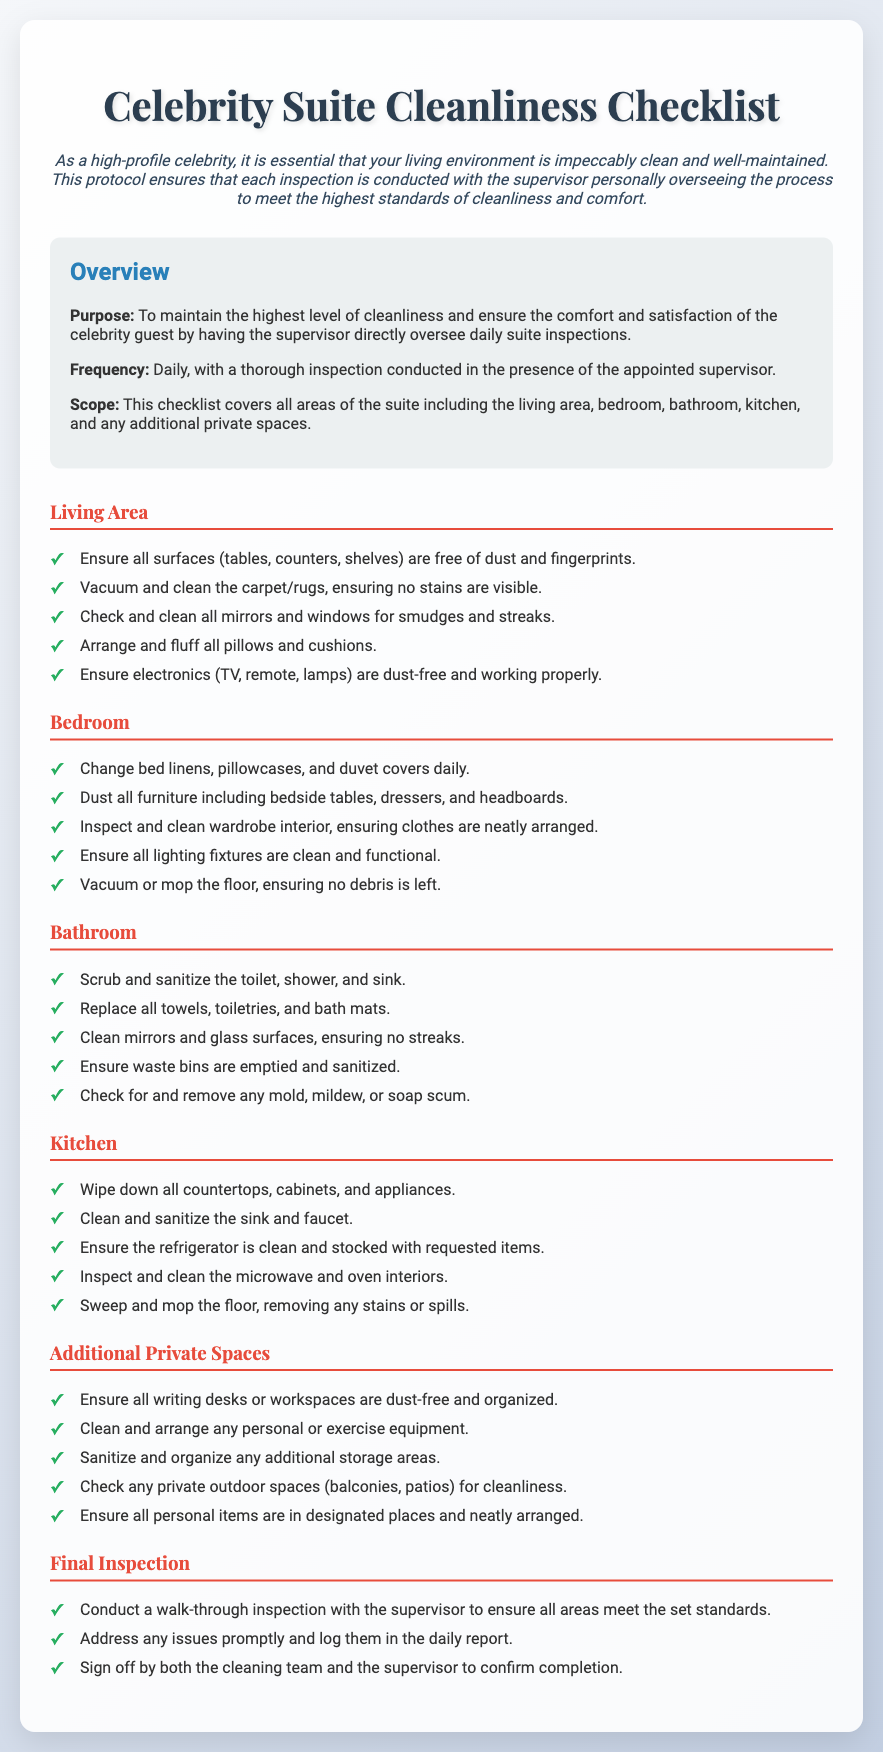What is the purpose of the checklist? The purpose is to maintain the highest level of cleanliness and ensure the comfort and satisfaction of the celebrity guest.
Answer: To maintain the highest level of cleanliness and ensure comfort How often is the inspection conducted? The frequency of the inspection is noted in the document, indicating how often the checklist should be used.
Answer: Daily What areas does the checklist cover? The scope of the checklist identifies the various spaces that need to be inspected.
Answer: Living area, bedroom, bathroom, kitchen, and additional private spaces Which category includes cleaning mirrors and windows? By examining the checklist categories, we can identify which area includes this task.
Answer: Living Area What should be done to the bed linens daily? This task is specifically outlined in the bedroom section of the checklist regarding bed maintenance.
Answer: Change bed linens Who oversees the inspection? The document specifies who is responsible for overseeing the inspections, highlighting their role in the protocol.
Answer: Supervisor What is the last step of the inspection process? The final inspection section details the concluding actions that must be taken after cleaning.
Answer: Conduct a walk-through inspection What is indicated must be emptied in the bathroom? This specific task is mentioned in the bathroom section of the checklist, indicating an item that requires attention.
Answer: Waste bins How should countertops in the kitchen be treated? This question arises from the kitchen category, indicating the cleaning action required.
Answer: Wipe down 